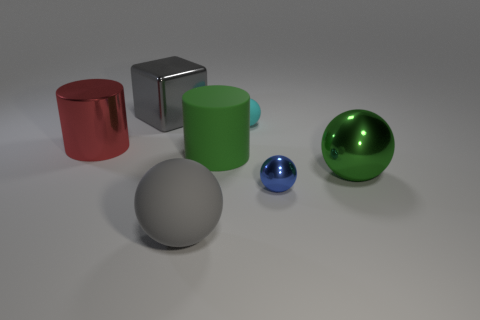How many other things are the same size as the block?
Keep it short and to the point. 4. What color is the big shiny cylinder?
Make the answer very short. Red. How many big things are either blue spheres or brown rubber cubes?
Offer a terse response. 0. Does the gray thing left of the large gray sphere have the same size as the matte thing left of the large green matte object?
Offer a very short reply. Yes. What size is the blue metal thing that is the same shape as the gray rubber object?
Your answer should be very brief. Small. Are there more tiny spheres behind the tiny metallic sphere than big green rubber cylinders that are to the right of the tiny cyan object?
Provide a short and direct response. Yes. The object that is to the right of the metallic block and behind the large red metallic cylinder is made of what material?
Your response must be concise. Rubber. There is another small metallic object that is the same shape as the cyan object; what is its color?
Offer a terse response. Blue. What is the size of the blue sphere?
Provide a succinct answer. Small. What color is the big thing that is behind the rubber object that is right of the big green matte cylinder?
Provide a succinct answer. Gray. 